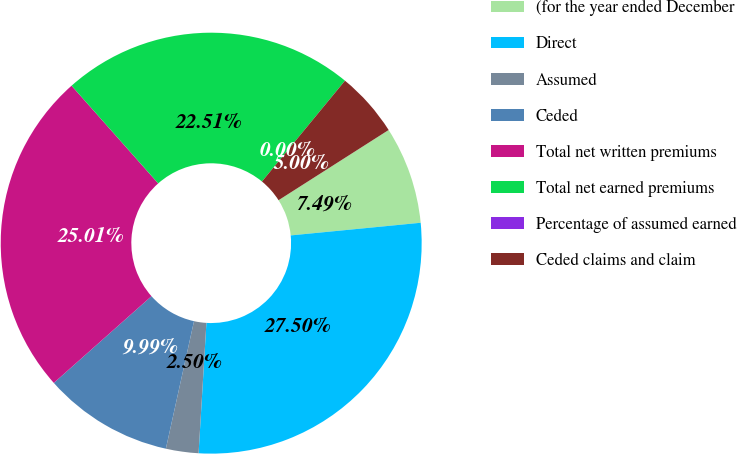<chart> <loc_0><loc_0><loc_500><loc_500><pie_chart><fcel>(for the year ended December<fcel>Direct<fcel>Assumed<fcel>Ceded<fcel>Total net written premiums<fcel>Total net earned premiums<fcel>Percentage of assumed earned<fcel>Ceded claims and claim<nl><fcel>7.49%<fcel>27.5%<fcel>2.5%<fcel>9.99%<fcel>25.01%<fcel>22.51%<fcel>0.0%<fcel>5.0%<nl></chart> 